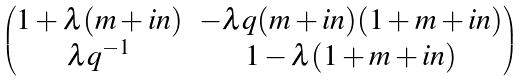Convert formula to latex. <formula><loc_0><loc_0><loc_500><loc_500>\begin{pmatrix} 1 + \lambda ( m + i n ) & - \lambda q ( m + i n ) ( 1 + m + i n ) \\ \lambda q ^ { - 1 } & 1 - \lambda ( 1 + m + i n ) \end{pmatrix}</formula> 